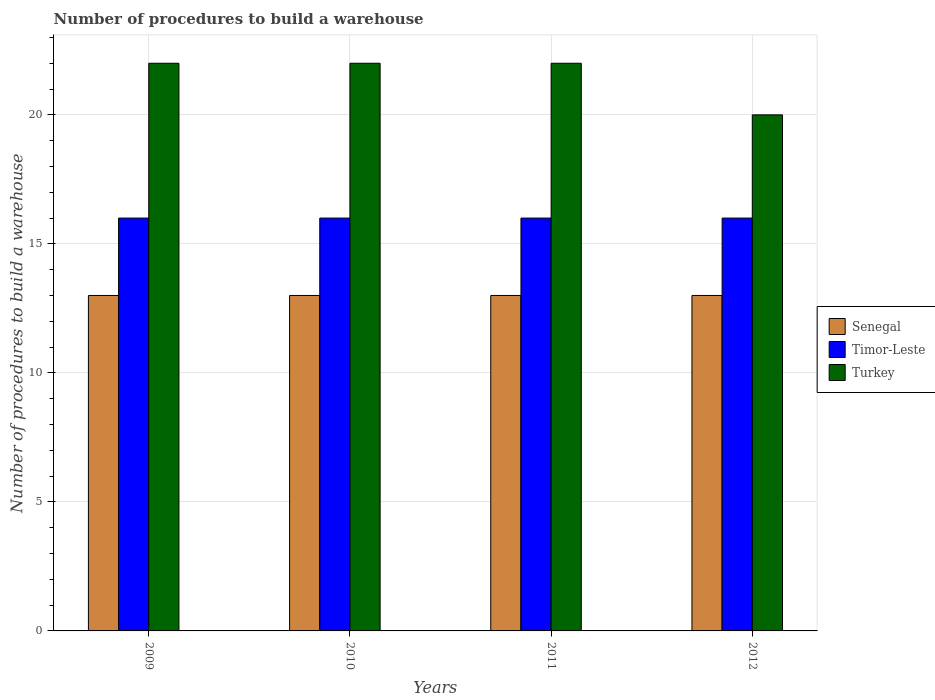Are the number of bars per tick equal to the number of legend labels?
Provide a succinct answer. Yes. Are the number of bars on each tick of the X-axis equal?
Give a very brief answer. Yes. How many bars are there on the 2nd tick from the right?
Your answer should be very brief. 3. In how many cases, is the number of bars for a given year not equal to the number of legend labels?
Provide a short and direct response. 0. What is the number of procedures to build a warehouse in in Senegal in 2012?
Offer a very short reply. 13. Across all years, what is the maximum number of procedures to build a warehouse in in Turkey?
Provide a short and direct response. 22. Across all years, what is the minimum number of procedures to build a warehouse in in Senegal?
Your response must be concise. 13. In which year was the number of procedures to build a warehouse in in Senegal maximum?
Provide a succinct answer. 2009. In which year was the number of procedures to build a warehouse in in Senegal minimum?
Provide a succinct answer. 2009. What is the total number of procedures to build a warehouse in in Timor-Leste in the graph?
Offer a very short reply. 64. What is the difference between the number of procedures to build a warehouse in in Timor-Leste in 2009 and that in 2011?
Your answer should be compact. 0. What is the difference between the number of procedures to build a warehouse in in Timor-Leste in 2011 and the number of procedures to build a warehouse in in Turkey in 2009?
Provide a short and direct response. -6. What is the average number of procedures to build a warehouse in in Timor-Leste per year?
Provide a succinct answer. 16. In the year 2009, what is the difference between the number of procedures to build a warehouse in in Senegal and number of procedures to build a warehouse in in Timor-Leste?
Keep it short and to the point. -3. In how many years, is the number of procedures to build a warehouse in in Turkey greater than 2?
Provide a succinct answer. 4. What is the difference between the highest and the second highest number of procedures to build a warehouse in in Senegal?
Keep it short and to the point. 0. What is the difference between the highest and the lowest number of procedures to build a warehouse in in Timor-Leste?
Your answer should be very brief. 0. In how many years, is the number of procedures to build a warehouse in in Senegal greater than the average number of procedures to build a warehouse in in Senegal taken over all years?
Make the answer very short. 0. What does the 3rd bar from the left in 2012 represents?
Provide a succinct answer. Turkey. Is it the case that in every year, the sum of the number of procedures to build a warehouse in in Senegal and number of procedures to build a warehouse in in Turkey is greater than the number of procedures to build a warehouse in in Timor-Leste?
Make the answer very short. Yes. Are the values on the major ticks of Y-axis written in scientific E-notation?
Your answer should be compact. No. Does the graph contain any zero values?
Your response must be concise. No. Where does the legend appear in the graph?
Your answer should be compact. Center right. How many legend labels are there?
Offer a very short reply. 3. How are the legend labels stacked?
Ensure brevity in your answer.  Vertical. What is the title of the graph?
Give a very brief answer. Number of procedures to build a warehouse. Does "Fiji" appear as one of the legend labels in the graph?
Give a very brief answer. No. What is the label or title of the Y-axis?
Your answer should be very brief. Number of procedures to build a warehouse. What is the Number of procedures to build a warehouse in Senegal in 2009?
Make the answer very short. 13. What is the Number of procedures to build a warehouse of Timor-Leste in 2009?
Your answer should be very brief. 16. What is the Number of procedures to build a warehouse of Turkey in 2010?
Ensure brevity in your answer.  22. What is the Number of procedures to build a warehouse in Senegal in 2011?
Provide a succinct answer. 13. What is the Number of procedures to build a warehouse in Timor-Leste in 2011?
Give a very brief answer. 16. What is the Number of procedures to build a warehouse in Turkey in 2012?
Keep it short and to the point. 20. Across all years, what is the maximum Number of procedures to build a warehouse in Senegal?
Ensure brevity in your answer.  13. Across all years, what is the maximum Number of procedures to build a warehouse in Timor-Leste?
Make the answer very short. 16. What is the total Number of procedures to build a warehouse of Senegal in the graph?
Give a very brief answer. 52. What is the difference between the Number of procedures to build a warehouse of Senegal in 2009 and that in 2010?
Keep it short and to the point. 0. What is the difference between the Number of procedures to build a warehouse in Timor-Leste in 2009 and that in 2011?
Offer a terse response. 0. What is the difference between the Number of procedures to build a warehouse of Turkey in 2009 and that in 2011?
Provide a succinct answer. 0. What is the difference between the Number of procedures to build a warehouse in Senegal in 2009 and that in 2012?
Make the answer very short. 0. What is the difference between the Number of procedures to build a warehouse of Turkey in 2009 and that in 2012?
Offer a terse response. 2. What is the difference between the Number of procedures to build a warehouse of Timor-Leste in 2010 and that in 2011?
Give a very brief answer. 0. What is the difference between the Number of procedures to build a warehouse of Senegal in 2011 and that in 2012?
Your response must be concise. 0. What is the difference between the Number of procedures to build a warehouse of Timor-Leste in 2011 and that in 2012?
Ensure brevity in your answer.  0. What is the difference between the Number of procedures to build a warehouse in Turkey in 2011 and that in 2012?
Your response must be concise. 2. What is the difference between the Number of procedures to build a warehouse of Senegal in 2009 and the Number of procedures to build a warehouse of Timor-Leste in 2010?
Offer a terse response. -3. What is the difference between the Number of procedures to build a warehouse of Senegal in 2009 and the Number of procedures to build a warehouse of Turkey in 2010?
Make the answer very short. -9. What is the difference between the Number of procedures to build a warehouse of Timor-Leste in 2009 and the Number of procedures to build a warehouse of Turkey in 2012?
Offer a very short reply. -4. What is the difference between the Number of procedures to build a warehouse of Senegal in 2010 and the Number of procedures to build a warehouse of Timor-Leste in 2012?
Give a very brief answer. -3. What is the difference between the Number of procedures to build a warehouse of Senegal in 2010 and the Number of procedures to build a warehouse of Turkey in 2012?
Your answer should be very brief. -7. What is the difference between the Number of procedures to build a warehouse in Senegal in 2011 and the Number of procedures to build a warehouse in Turkey in 2012?
Your response must be concise. -7. What is the average Number of procedures to build a warehouse of Senegal per year?
Make the answer very short. 13. What is the average Number of procedures to build a warehouse of Turkey per year?
Keep it short and to the point. 21.5. In the year 2009, what is the difference between the Number of procedures to build a warehouse in Senegal and Number of procedures to build a warehouse in Timor-Leste?
Your answer should be very brief. -3. In the year 2009, what is the difference between the Number of procedures to build a warehouse in Senegal and Number of procedures to build a warehouse in Turkey?
Offer a terse response. -9. In the year 2010, what is the difference between the Number of procedures to build a warehouse in Timor-Leste and Number of procedures to build a warehouse in Turkey?
Your answer should be very brief. -6. In the year 2011, what is the difference between the Number of procedures to build a warehouse in Senegal and Number of procedures to build a warehouse in Timor-Leste?
Your response must be concise. -3. In the year 2011, what is the difference between the Number of procedures to build a warehouse in Senegal and Number of procedures to build a warehouse in Turkey?
Give a very brief answer. -9. In the year 2012, what is the difference between the Number of procedures to build a warehouse in Senegal and Number of procedures to build a warehouse in Timor-Leste?
Provide a short and direct response. -3. In the year 2012, what is the difference between the Number of procedures to build a warehouse in Senegal and Number of procedures to build a warehouse in Turkey?
Provide a succinct answer. -7. What is the ratio of the Number of procedures to build a warehouse of Senegal in 2009 to that in 2010?
Keep it short and to the point. 1. What is the ratio of the Number of procedures to build a warehouse in Senegal in 2009 to that in 2011?
Offer a terse response. 1. What is the ratio of the Number of procedures to build a warehouse of Timor-Leste in 2009 to that in 2011?
Ensure brevity in your answer.  1. What is the ratio of the Number of procedures to build a warehouse of Turkey in 2009 to that in 2012?
Ensure brevity in your answer.  1.1. What is the ratio of the Number of procedures to build a warehouse of Timor-Leste in 2010 to that in 2011?
Keep it short and to the point. 1. What is the ratio of the Number of procedures to build a warehouse in Turkey in 2010 to that in 2011?
Provide a short and direct response. 1. What is the ratio of the Number of procedures to build a warehouse in Timor-Leste in 2010 to that in 2012?
Provide a short and direct response. 1. What is the difference between the highest and the second highest Number of procedures to build a warehouse of Timor-Leste?
Your response must be concise. 0. What is the difference between the highest and the second highest Number of procedures to build a warehouse in Turkey?
Your answer should be compact. 0. 